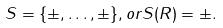<formula> <loc_0><loc_0><loc_500><loc_500>S = \{ \pm , \dots , \pm \} , o r S ( R ) = \pm .</formula> 